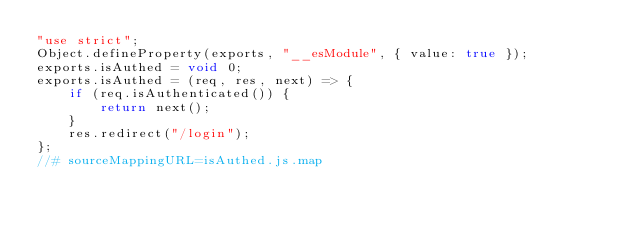<code> <loc_0><loc_0><loc_500><loc_500><_JavaScript_>"use strict";
Object.defineProperty(exports, "__esModule", { value: true });
exports.isAuthed = void 0;
exports.isAuthed = (req, res, next) => {
    if (req.isAuthenticated()) {
        return next();
    }
    res.redirect("/login");
};
//# sourceMappingURL=isAuthed.js.map</code> 